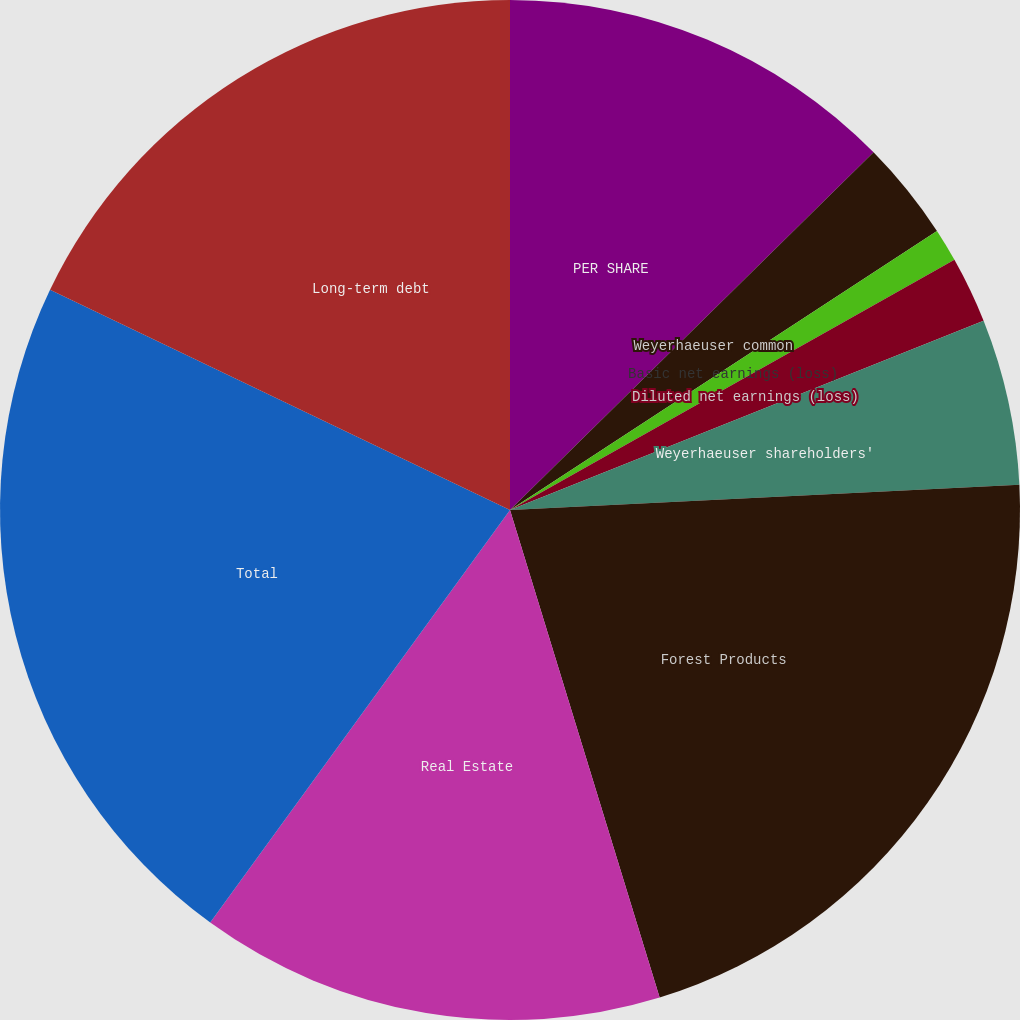Convert chart to OTSL. <chart><loc_0><loc_0><loc_500><loc_500><pie_chart><fcel>PER SHARE<fcel>Weyerhaeuser common<fcel>Basic net earnings (loss)<fcel>Diluted net earnings (loss)<fcel>Dividends paid<fcel>Weyerhaeuser shareholders'<fcel>Forest Products<fcel>Real Estate<fcel>Total<fcel>Long-term debt<nl><fcel>12.63%<fcel>3.16%<fcel>1.05%<fcel>2.11%<fcel>0.0%<fcel>5.26%<fcel>21.05%<fcel>14.74%<fcel>22.11%<fcel>17.89%<nl></chart> 